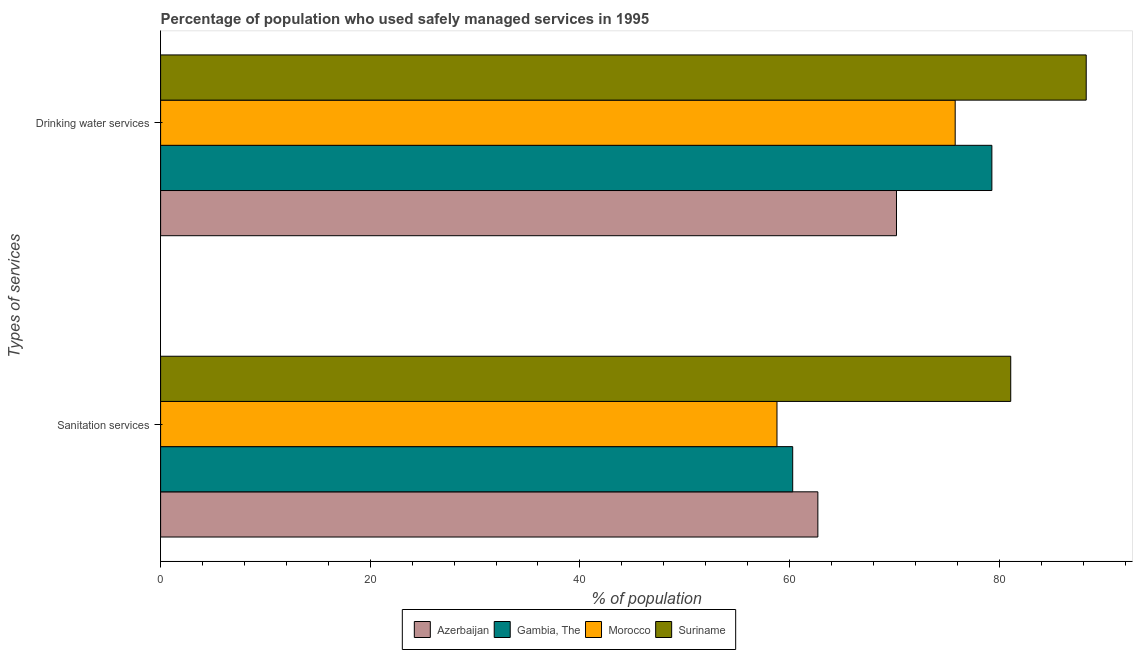How many bars are there on the 2nd tick from the bottom?
Offer a very short reply. 4. What is the label of the 1st group of bars from the top?
Your answer should be very brief. Drinking water services. What is the percentage of population who used drinking water services in Azerbaijan?
Your answer should be very brief. 70.2. Across all countries, what is the maximum percentage of population who used drinking water services?
Offer a very short reply. 88.3. Across all countries, what is the minimum percentage of population who used sanitation services?
Offer a very short reply. 58.8. In which country was the percentage of population who used sanitation services maximum?
Your answer should be compact. Suriname. In which country was the percentage of population who used sanitation services minimum?
Give a very brief answer. Morocco. What is the total percentage of population who used drinking water services in the graph?
Provide a succinct answer. 313.6. What is the difference between the percentage of population who used sanitation services in Morocco and that in Suriname?
Offer a terse response. -22.3. What is the difference between the percentage of population who used sanitation services in Suriname and the percentage of population who used drinking water services in Azerbaijan?
Give a very brief answer. 10.9. What is the average percentage of population who used sanitation services per country?
Your answer should be very brief. 65.72. What is the ratio of the percentage of population who used drinking water services in Gambia, The to that in Morocco?
Make the answer very short. 1.05. Is the percentage of population who used sanitation services in Morocco less than that in Azerbaijan?
Give a very brief answer. Yes. In how many countries, is the percentage of population who used drinking water services greater than the average percentage of population who used drinking water services taken over all countries?
Offer a very short reply. 2. What does the 2nd bar from the top in Sanitation services represents?
Keep it short and to the point. Morocco. What does the 2nd bar from the bottom in Sanitation services represents?
Your response must be concise. Gambia, The. How many bars are there?
Keep it short and to the point. 8. How many countries are there in the graph?
Offer a terse response. 4. Where does the legend appear in the graph?
Give a very brief answer. Bottom center. How are the legend labels stacked?
Your response must be concise. Horizontal. What is the title of the graph?
Keep it short and to the point. Percentage of population who used safely managed services in 1995. What is the label or title of the X-axis?
Provide a succinct answer. % of population. What is the label or title of the Y-axis?
Make the answer very short. Types of services. What is the % of population in Azerbaijan in Sanitation services?
Ensure brevity in your answer.  62.7. What is the % of population of Gambia, The in Sanitation services?
Ensure brevity in your answer.  60.3. What is the % of population of Morocco in Sanitation services?
Offer a terse response. 58.8. What is the % of population in Suriname in Sanitation services?
Give a very brief answer. 81.1. What is the % of population in Azerbaijan in Drinking water services?
Your answer should be very brief. 70.2. What is the % of population of Gambia, The in Drinking water services?
Provide a succinct answer. 79.3. What is the % of population in Morocco in Drinking water services?
Ensure brevity in your answer.  75.8. What is the % of population in Suriname in Drinking water services?
Your response must be concise. 88.3. Across all Types of services, what is the maximum % of population of Azerbaijan?
Make the answer very short. 70.2. Across all Types of services, what is the maximum % of population in Gambia, The?
Give a very brief answer. 79.3. Across all Types of services, what is the maximum % of population in Morocco?
Give a very brief answer. 75.8. Across all Types of services, what is the maximum % of population of Suriname?
Make the answer very short. 88.3. Across all Types of services, what is the minimum % of population of Azerbaijan?
Provide a succinct answer. 62.7. Across all Types of services, what is the minimum % of population of Gambia, The?
Offer a very short reply. 60.3. Across all Types of services, what is the minimum % of population in Morocco?
Ensure brevity in your answer.  58.8. Across all Types of services, what is the minimum % of population in Suriname?
Your answer should be compact. 81.1. What is the total % of population of Azerbaijan in the graph?
Give a very brief answer. 132.9. What is the total % of population of Gambia, The in the graph?
Ensure brevity in your answer.  139.6. What is the total % of population in Morocco in the graph?
Keep it short and to the point. 134.6. What is the total % of population in Suriname in the graph?
Offer a terse response. 169.4. What is the difference between the % of population in Azerbaijan in Sanitation services and the % of population in Gambia, The in Drinking water services?
Make the answer very short. -16.6. What is the difference between the % of population in Azerbaijan in Sanitation services and the % of population in Suriname in Drinking water services?
Your answer should be compact. -25.6. What is the difference between the % of population of Gambia, The in Sanitation services and the % of population of Morocco in Drinking water services?
Your response must be concise. -15.5. What is the difference between the % of population of Morocco in Sanitation services and the % of population of Suriname in Drinking water services?
Offer a terse response. -29.5. What is the average % of population in Azerbaijan per Types of services?
Your answer should be compact. 66.45. What is the average % of population of Gambia, The per Types of services?
Your response must be concise. 69.8. What is the average % of population in Morocco per Types of services?
Make the answer very short. 67.3. What is the average % of population in Suriname per Types of services?
Provide a short and direct response. 84.7. What is the difference between the % of population of Azerbaijan and % of population of Morocco in Sanitation services?
Make the answer very short. 3.9. What is the difference between the % of population in Azerbaijan and % of population in Suriname in Sanitation services?
Make the answer very short. -18.4. What is the difference between the % of population of Gambia, The and % of population of Morocco in Sanitation services?
Your answer should be compact. 1.5. What is the difference between the % of population in Gambia, The and % of population in Suriname in Sanitation services?
Provide a succinct answer. -20.8. What is the difference between the % of population in Morocco and % of population in Suriname in Sanitation services?
Provide a short and direct response. -22.3. What is the difference between the % of population in Azerbaijan and % of population in Morocco in Drinking water services?
Your answer should be very brief. -5.6. What is the difference between the % of population of Azerbaijan and % of population of Suriname in Drinking water services?
Keep it short and to the point. -18.1. What is the difference between the % of population of Gambia, The and % of population of Morocco in Drinking water services?
Your answer should be compact. 3.5. What is the difference between the % of population in Gambia, The and % of population in Suriname in Drinking water services?
Ensure brevity in your answer.  -9. What is the difference between the % of population of Morocco and % of population of Suriname in Drinking water services?
Your response must be concise. -12.5. What is the ratio of the % of population in Azerbaijan in Sanitation services to that in Drinking water services?
Make the answer very short. 0.89. What is the ratio of the % of population in Gambia, The in Sanitation services to that in Drinking water services?
Offer a terse response. 0.76. What is the ratio of the % of population in Morocco in Sanitation services to that in Drinking water services?
Provide a succinct answer. 0.78. What is the ratio of the % of population in Suriname in Sanitation services to that in Drinking water services?
Your answer should be compact. 0.92. What is the difference between the highest and the second highest % of population in Gambia, The?
Provide a succinct answer. 19. What is the difference between the highest and the lowest % of population of Azerbaijan?
Keep it short and to the point. 7.5. 